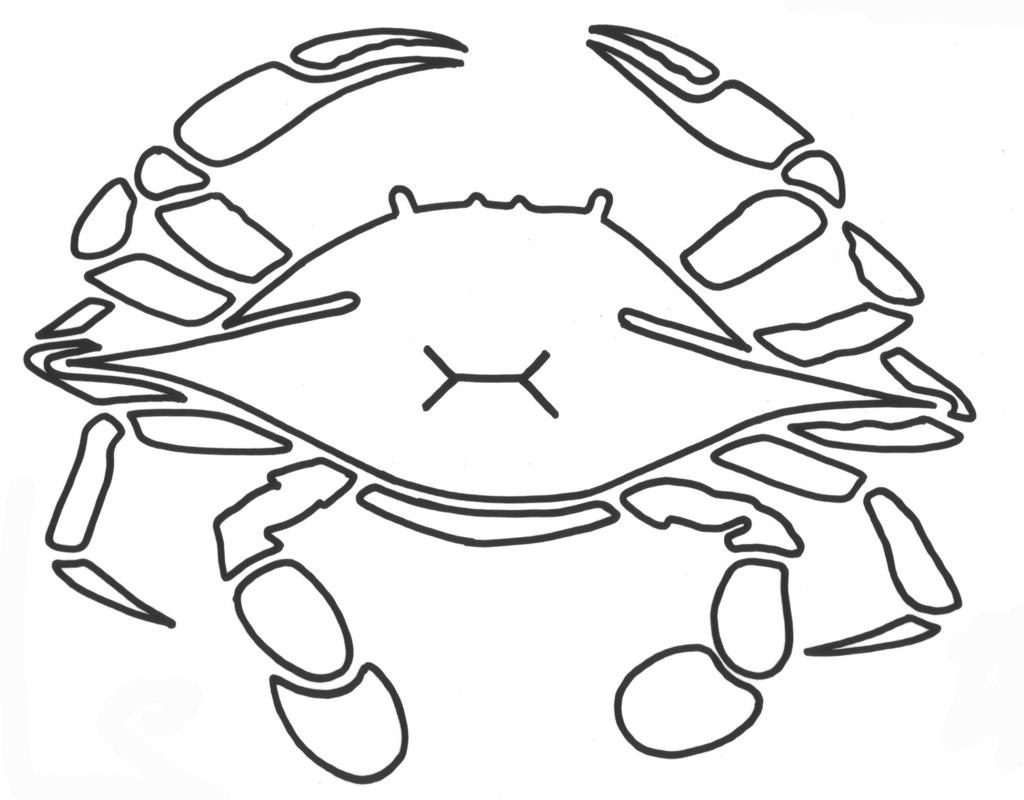What type of drawing is shown in the image? The image is a sketch. What subject is depicted in the sketch? The sketch depicts a crab. How does the crab show its love for the attention it receives in the image? The image does not depict the crab showing love or receiving attention, as it is a simple sketch of a crab. 